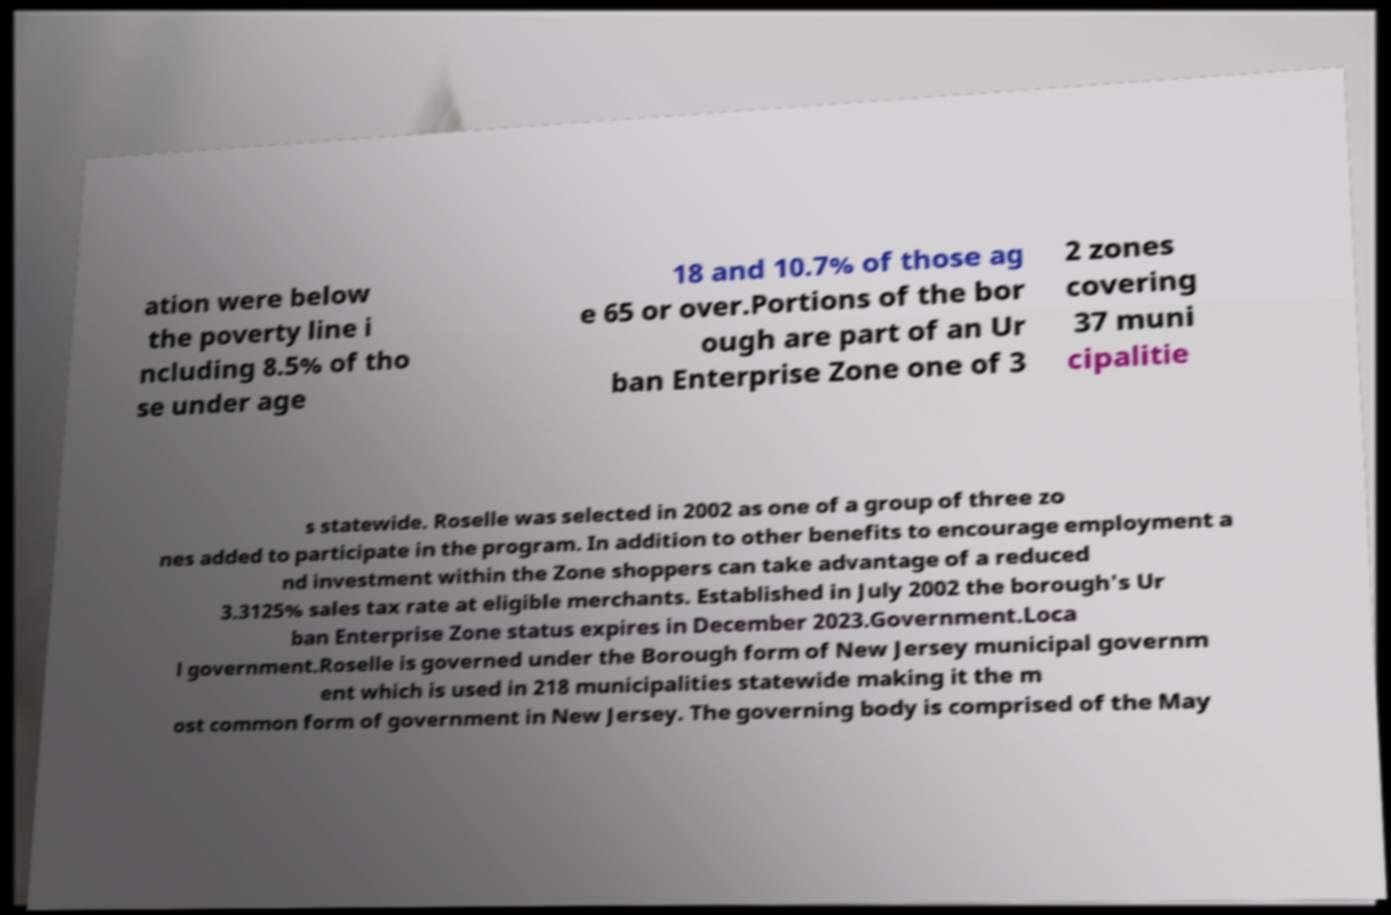Can you accurately transcribe the text from the provided image for me? ation were below the poverty line i ncluding 8.5% of tho se under age 18 and 10.7% of those ag e 65 or over.Portions of the bor ough are part of an Ur ban Enterprise Zone one of 3 2 zones covering 37 muni cipalitie s statewide. Roselle was selected in 2002 as one of a group of three zo nes added to participate in the program. In addition to other benefits to encourage employment a nd investment within the Zone shoppers can take advantage of a reduced 3.3125% sales tax rate at eligible merchants. Established in July 2002 the borough's Ur ban Enterprise Zone status expires in December 2023.Government.Loca l government.Roselle is governed under the Borough form of New Jersey municipal governm ent which is used in 218 municipalities statewide making it the m ost common form of government in New Jersey. The governing body is comprised of the May 